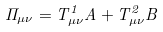<formula> <loc_0><loc_0><loc_500><loc_500>\Pi _ { \mu \nu } = T _ { \mu \nu } ^ { 1 } A + T _ { \mu \nu } ^ { 2 } B</formula> 